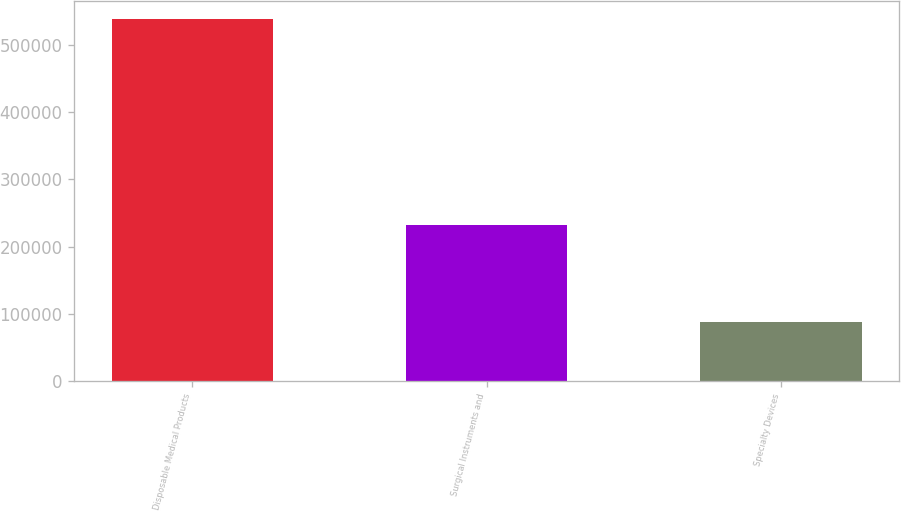Convert chart. <chart><loc_0><loc_0><loc_500><loc_500><bar_chart><fcel>Disposable Medical Products<fcel>Surgical Instruments and<fcel>Specialty Devices<nl><fcel>538859<fcel>232555<fcel>87262<nl></chart> 